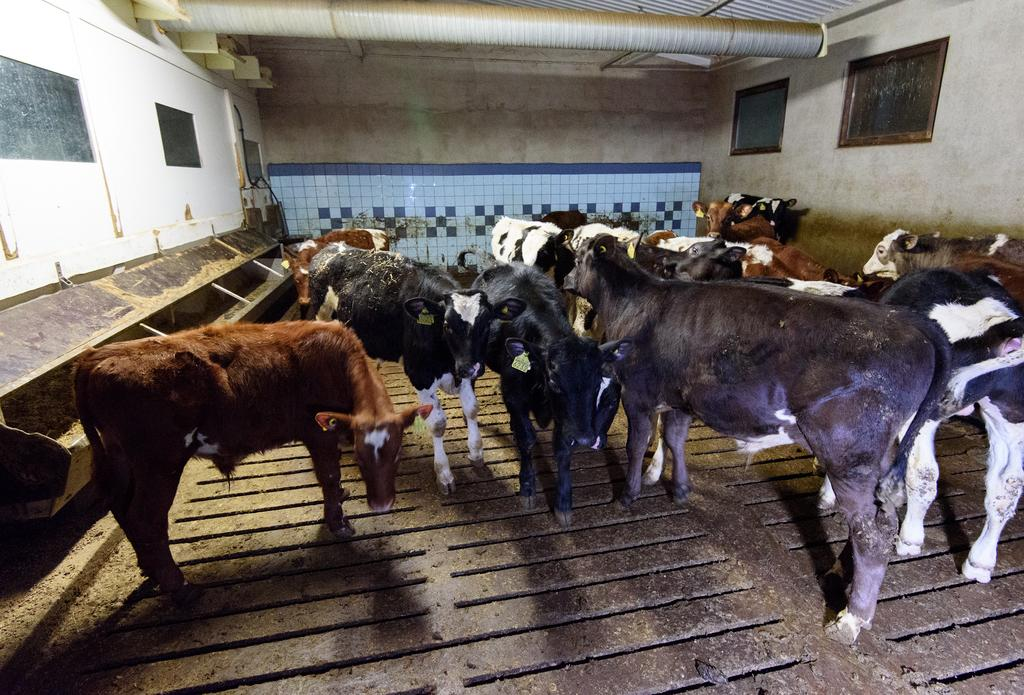What type of animals can be seen in the image? There is a herd of cows in the image. What architectural features are present in the image? There are windows and a wall in the image. What can be seen at the top of the image? There is a pipe at the top of the image. How many cars are parked near the cows in the image? There are no cars present in the image; it features a herd of cows and other architectural elements. What type of parcel is being delivered to the cows in the image? There is no parcel or delivery being depicted in the image; it only shows a herd of cows and other architectural elements. 